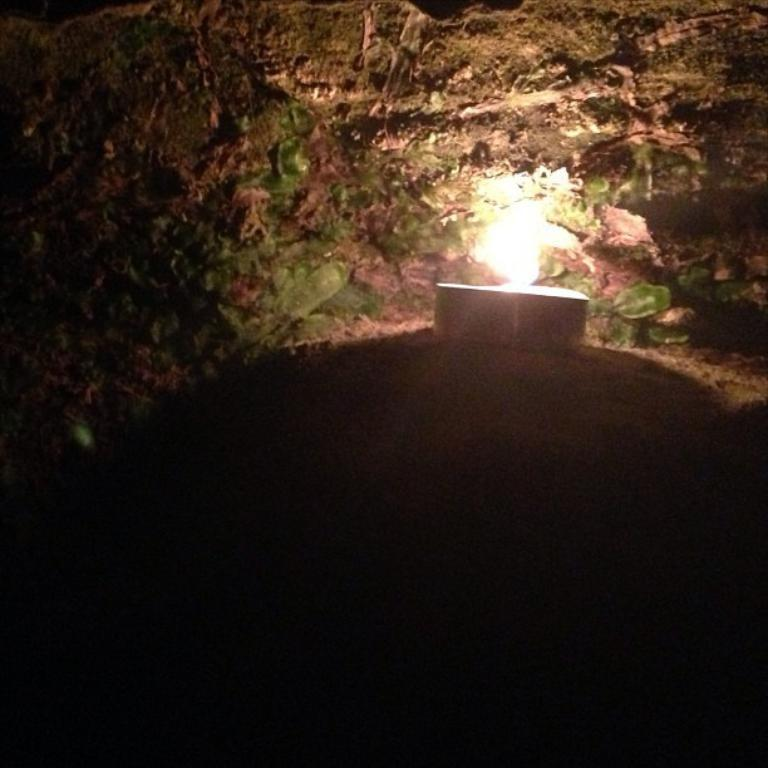What object in the image has a flame? The candle in the image has a flame. Where is the candle located in the image? The candle is placed on the ground. How does the candle weigh itself on a scale in the image? There is no scale present in the image, and candles do not have the ability to weigh themselves. What type of machine is visible in the image? There is no machine present in the image. 